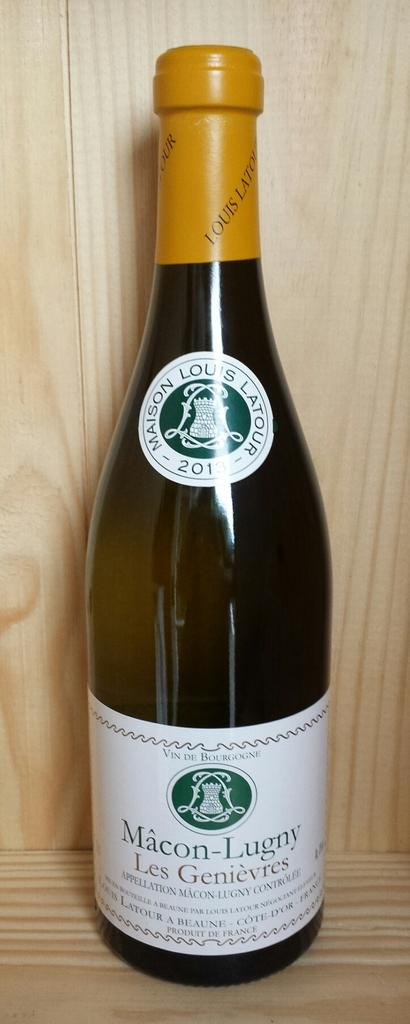<image>
Provide a brief description of the given image. A wine bottle that says Macon-Lugny Les Genievres. 